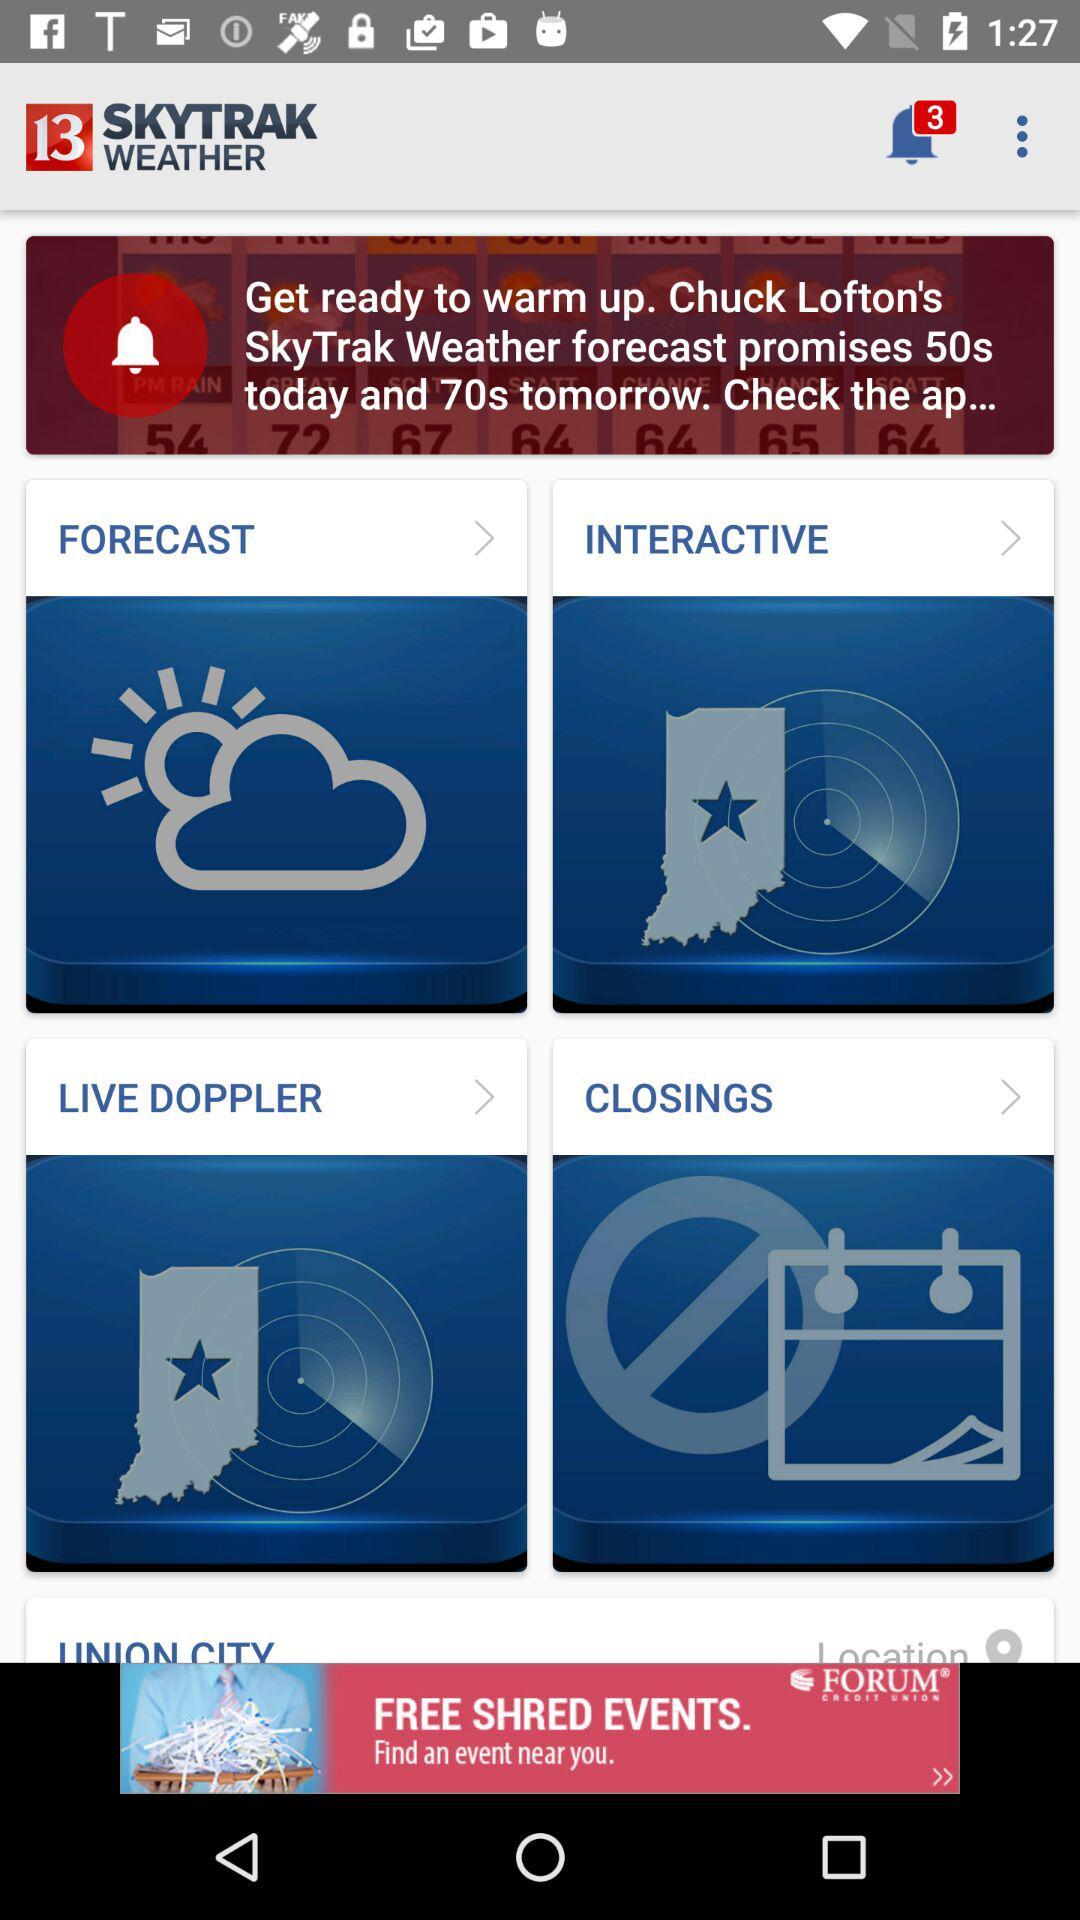Are there any unread notifications? There are 3 unread notifications. 